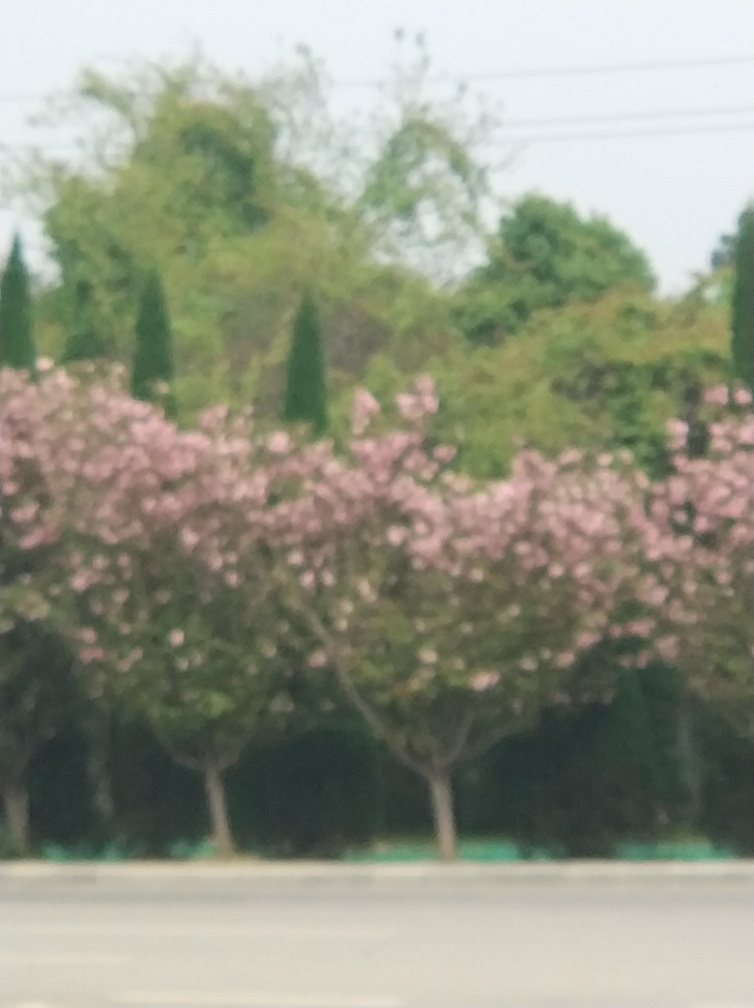Are there any chromatic aberrations? Based on my analysis of the image, there appear to be no distinct signs of chromatic aberrations, which are typically visible as colored fringes along the edges of high-contrast sections in a photo. The blurriness present is more indicative of an out-of-focus shot rather than a chromatic defect. 